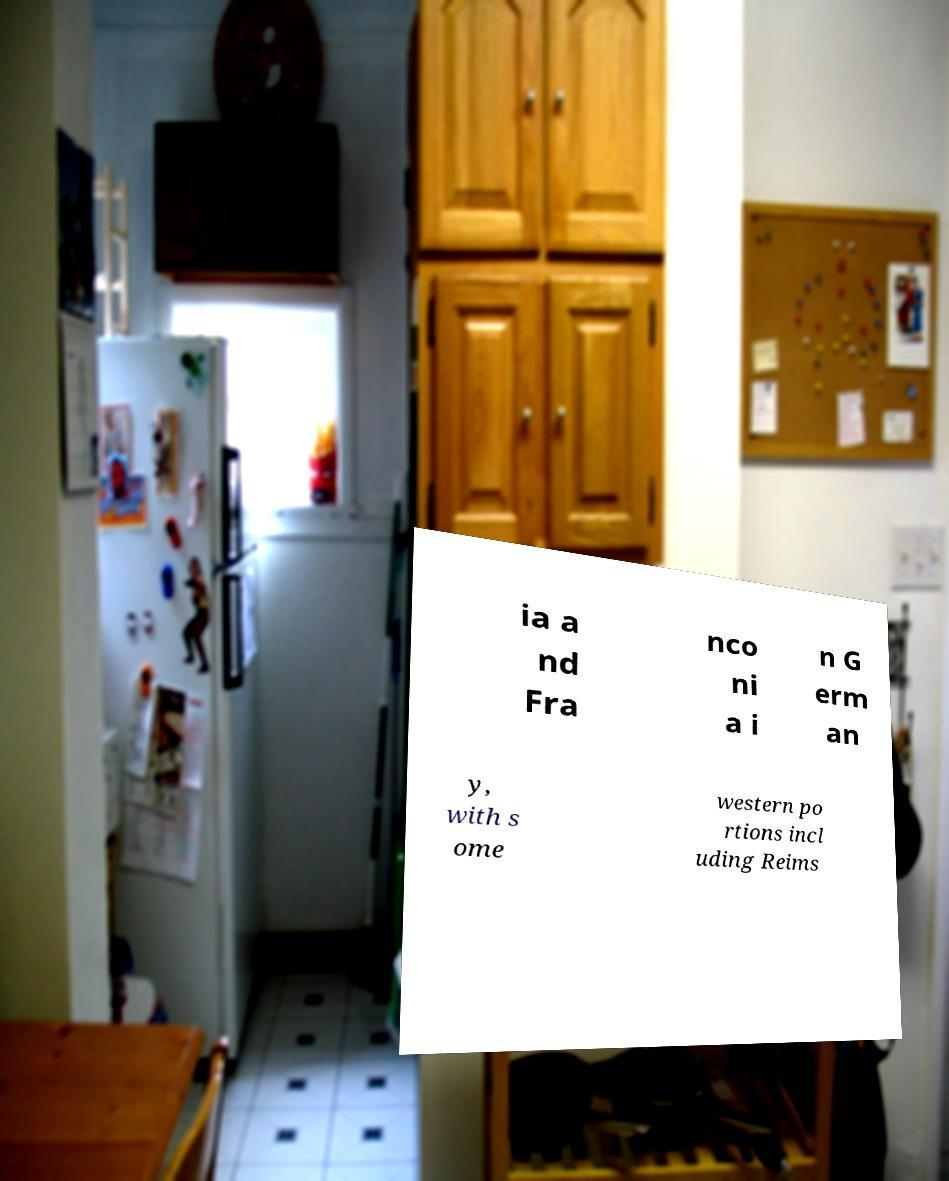Please read and relay the text visible in this image. What does it say? ia a nd Fra nco ni a i n G erm an y, with s ome western po rtions incl uding Reims 